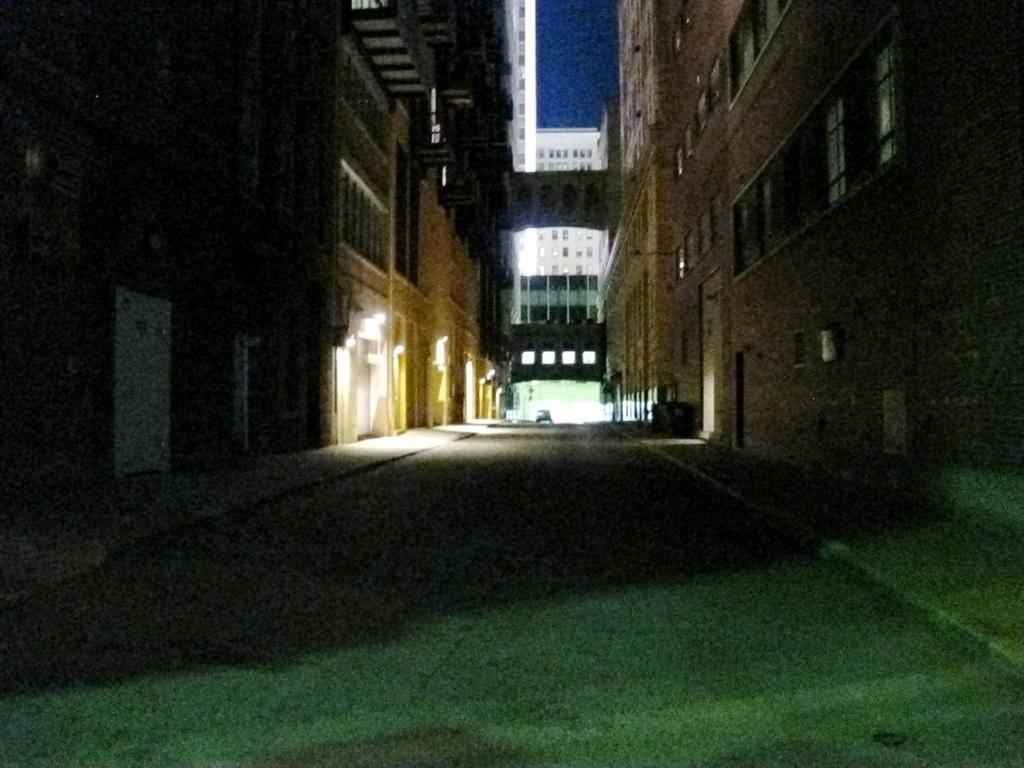What is the main subject in the center of the image? There is a car in the center of the image. What can be seen on the right side of the image? There are buildings on the right side of the image. What can be seen on the left side of the image? There are buildings on the left side of the image. What is visible in the background of the image? There is a building and the sky visible in the background of the image. What type of shoe can be seen on the roof of the building in the image? There is no shoe present on the roof of any building in the image. 